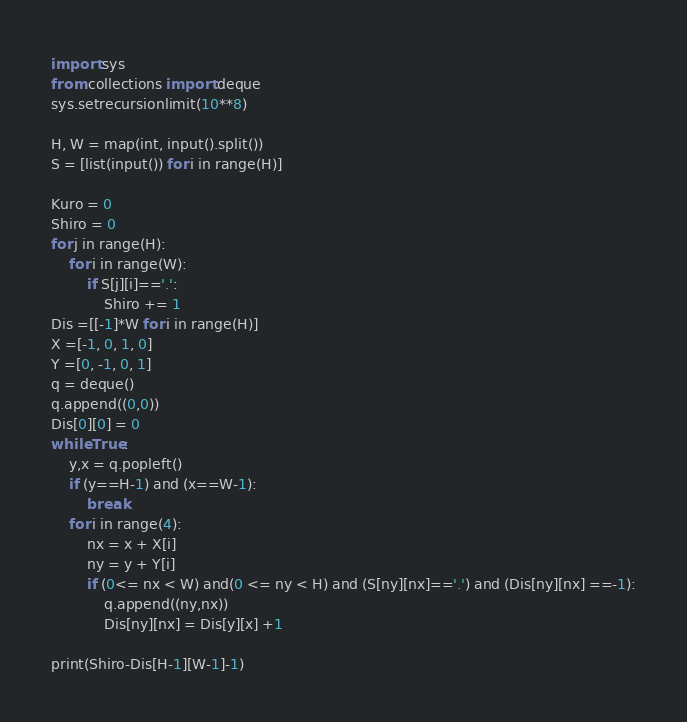<code> <loc_0><loc_0><loc_500><loc_500><_Python_>import sys
from collections import deque
sys.setrecursionlimit(10**8)

H, W = map(int, input().split()) 
S = [list(input()) for i in range(H)]

Kuro = 0
Shiro = 0
for j in range(H):
    for i in range(W):
        if S[j][i]=='.':
            Shiro += 1
Dis =[[-1]*W for i in range(H)]
X =[-1, 0, 1, 0]
Y =[0, -1, 0, 1]
q = deque()
q.append((0,0))
Dis[0][0] = 0
while True:
    y,x = q.popleft()
    if (y==H-1) and (x==W-1):
        break
    for i in range(4):
        nx = x + X[i]
        ny = y + Y[i]
        if (0<= nx < W) and(0 <= ny < H) and (S[ny][nx]=='.') and (Dis[ny][nx] ==-1):
            q.append((ny,nx))
            Dis[ny][nx] = Dis[y][x] +1

print(Shiro-Dis[H-1][W-1]-1)    </code> 